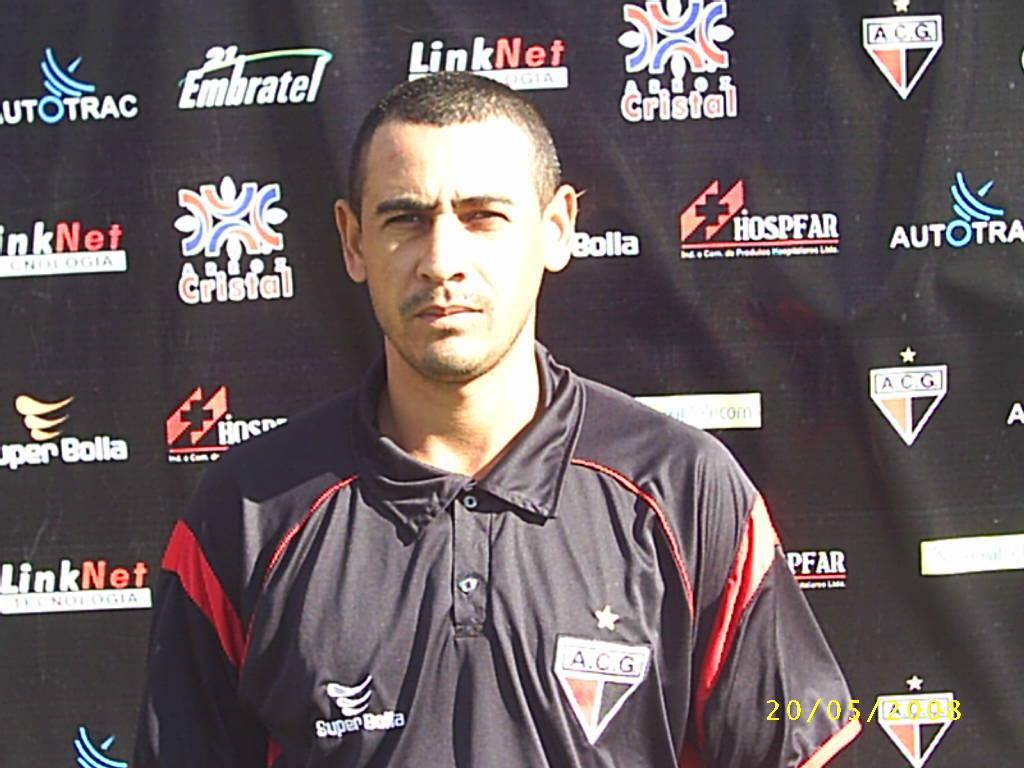<image>
Offer a succinct explanation of the picture presented. A man poses for the photo wearing a black shirt that has a logo "A.C.G" on the left. 